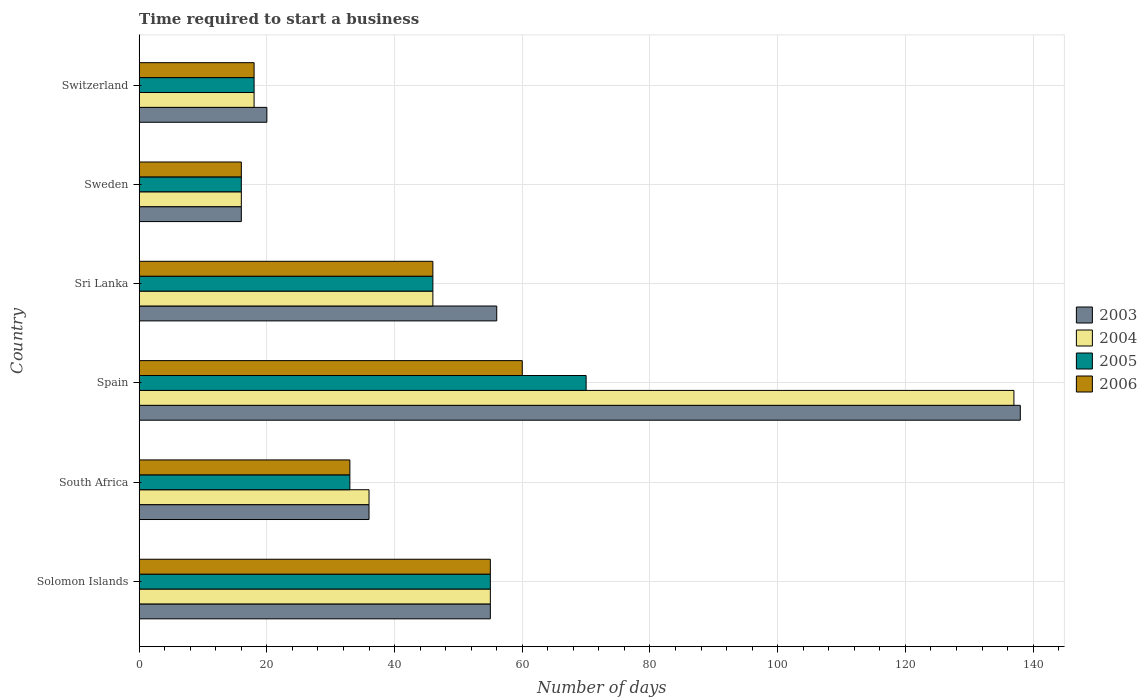How many groups of bars are there?
Your response must be concise. 6. Are the number of bars per tick equal to the number of legend labels?
Your answer should be compact. Yes. Are the number of bars on each tick of the Y-axis equal?
Keep it short and to the point. Yes. In how many cases, is the number of bars for a given country not equal to the number of legend labels?
Make the answer very short. 0. Across all countries, what is the maximum number of days required to start a business in 2004?
Make the answer very short. 137. In which country was the number of days required to start a business in 2006 maximum?
Give a very brief answer. Spain. What is the total number of days required to start a business in 2005 in the graph?
Provide a succinct answer. 238. What is the average number of days required to start a business in 2004 per country?
Your answer should be very brief. 51.33. What is the difference between the number of days required to start a business in 2004 and number of days required to start a business in 2006 in Switzerland?
Give a very brief answer. 0. In how many countries, is the number of days required to start a business in 2004 greater than 20 days?
Keep it short and to the point. 4. What is the ratio of the number of days required to start a business in 2005 in Solomon Islands to that in Sri Lanka?
Provide a succinct answer. 1.2. Is the difference between the number of days required to start a business in 2004 in South Africa and Spain greater than the difference between the number of days required to start a business in 2006 in South Africa and Spain?
Your response must be concise. No. What is the difference between the highest and the second highest number of days required to start a business in 2005?
Offer a terse response. 15. In how many countries, is the number of days required to start a business in 2003 greater than the average number of days required to start a business in 2003 taken over all countries?
Provide a short and direct response. 3. Is the sum of the number of days required to start a business in 2006 in Solomon Islands and Spain greater than the maximum number of days required to start a business in 2004 across all countries?
Provide a short and direct response. No. Is it the case that in every country, the sum of the number of days required to start a business in 2004 and number of days required to start a business in 2005 is greater than the number of days required to start a business in 2006?
Provide a short and direct response. Yes. How many bars are there?
Your response must be concise. 24. How many countries are there in the graph?
Give a very brief answer. 6. Are the values on the major ticks of X-axis written in scientific E-notation?
Provide a succinct answer. No. Does the graph contain any zero values?
Provide a succinct answer. No. Does the graph contain grids?
Keep it short and to the point. Yes. Where does the legend appear in the graph?
Keep it short and to the point. Center right. What is the title of the graph?
Offer a very short reply. Time required to start a business. Does "1990" appear as one of the legend labels in the graph?
Make the answer very short. No. What is the label or title of the X-axis?
Offer a terse response. Number of days. What is the label or title of the Y-axis?
Your answer should be very brief. Country. What is the Number of days of 2004 in South Africa?
Give a very brief answer. 36. What is the Number of days of 2006 in South Africa?
Your response must be concise. 33. What is the Number of days in 2003 in Spain?
Ensure brevity in your answer.  138. What is the Number of days in 2004 in Spain?
Give a very brief answer. 137. What is the Number of days in 2005 in Spain?
Provide a short and direct response. 70. What is the Number of days in 2006 in Spain?
Ensure brevity in your answer.  60. What is the Number of days in 2004 in Sri Lanka?
Your answer should be very brief. 46. What is the Number of days in 2004 in Sweden?
Offer a very short reply. 16. What is the Number of days in 2005 in Sweden?
Give a very brief answer. 16. What is the Number of days of 2006 in Sweden?
Provide a succinct answer. 16. What is the Number of days in 2003 in Switzerland?
Your response must be concise. 20. Across all countries, what is the maximum Number of days of 2003?
Make the answer very short. 138. Across all countries, what is the maximum Number of days of 2004?
Keep it short and to the point. 137. Across all countries, what is the maximum Number of days in 2005?
Make the answer very short. 70. Across all countries, what is the minimum Number of days of 2003?
Offer a terse response. 16. Across all countries, what is the minimum Number of days of 2004?
Offer a very short reply. 16. What is the total Number of days of 2003 in the graph?
Give a very brief answer. 321. What is the total Number of days of 2004 in the graph?
Give a very brief answer. 308. What is the total Number of days of 2005 in the graph?
Make the answer very short. 238. What is the total Number of days in 2006 in the graph?
Give a very brief answer. 228. What is the difference between the Number of days in 2005 in Solomon Islands and that in South Africa?
Provide a short and direct response. 22. What is the difference between the Number of days in 2003 in Solomon Islands and that in Spain?
Keep it short and to the point. -83. What is the difference between the Number of days of 2004 in Solomon Islands and that in Spain?
Keep it short and to the point. -82. What is the difference between the Number of days of 2006 in Solomon Islands and that in Spain?
Your answer should be compact. -5. What is the difference between the Number of days in 2004 in Solomon Islands and that in Sri Lanka?
Offer a terse response. 9. What is the difference between the Number of days in 2005 in Solomon Islands and that in Sri Lanka?
Your response must be concise. 9. What is the difference between the Number of days of 2003 in Solomon Islands and that in Sweden?
Your answer should be very brief. 39. What is the difference between the Number of days of 2005 in Solomon Islands and that in Sweden?
Your answer should be very brief. 39. What is the difference between the Number of days in 2006 in Solomon Islands and that in Sweden?
Your response must be concise. 39. What is the difference between the Number of days of 2004 in Solomon Islands and that in Switzerland?
Provide a succinct answer. 37. What is the difference between the Number of days in 2003 in South Africa and that in Spain?
Make the answer very short. -102. What is the difference between the Number of days of 2004 in South Africa and that in Spain?
Provide a short and direct response. -101. What is the difference between the Number of days of 2005 in South Africa and that in Spain?
Provide a succinct answer. -37. What is the difference between the Number of days in 2004 in South Africa and that in Sri Lanka?
Your answer should be very brief. -10. What is the difference between the Number of days of 2004 in South Africa and that in Sweden?
Provide a succinct answer. 20. What is the difference between the Number of days in 2006 in South Africa and that in Sweden?
Your response must be concise. 17. What is the difference between the Number of days of 2004 in South Africa and that in Switzerland?
Ensure brevity in your answer.  18. What is the difference between the Number of days in 2003 in Spain and that in Sri Lanka?
Give a very brief answer. 82. What is the difference between the Number of days of 2004 in Spain and that in Sri Lanka?
Give a very brief answer. 91. What is the difference between the Number of days of 2006 in Spain and that in Sri Lanka?
Provide a short and direct response. 14. What is the difference between the Number of days of 2003 in Spain and that in Sweden?
Your answer should be compact. 122. What is the difference between the Number of days of 2004 in Spain and that in Sweden?
Provide a short and direct response. 121. What is the difference between the Number of days of 2003 in Spain and that in Switzerland?
Provide a succinct answer. 118. What is the difference between the Number of days in 2004 in Spain and that in Switzerland?
Your response must be concise. 119. What is the difference between the Number of days in 2003 in Sri Lanka and that in Sweden?
Your response must be concise. 40. What is the difference between the Number of days in 2004 in Sri Lanka and that in Sweden?
Offer a terse response. 30. What is the difference between the Number of days of 2005 in Sri Lanka and that in Sweden?
Your answer should be compact. 30. What is the difference between the Number of days in 2003 in Sri Lanka and that in Switzerland?
Offer a very short reply. 36. What is the difference between the Number of days in 2003 in Sweden and that in Switzerland?
Keep it short and to the point. -4. What is the difference between the Number of days in 2003 in Solomon Islands and the Number of days in 2006 in South Africa?
Ensure brevity in your answer.  22. What is the difference between the Number of days in 2004 in Solomon Islands and the Number of days in 2005 in South Africa?
Your response must be concise. 22. What is the difference between the Number of days of 2003 in Solomon Islands and the Number of days of 2004 in Spain?
Make the answer very short. -82. What is the difference between the Number of days in 2003 in Solomon Islands and the Number of days in 2005 in Spain?
Provide a short and direct response. -15. What is the difference between the Number of days of 2003 in Solomon Islands and the Number of days of 2006 in Spain?
Offer a terse response. -5. What is the difference between the Number of days of 2004 in Solomon Islands and the Number of days of 2005 in Spain?
Ensure brevity in your answer.  -15. What is the difference between the Number of days in 2003 in Solomon Islands and the Number of days in 2004 in Sri Lanka?
Make the answer very short. 9. What is the difference between the Number of days in 2003 in Solomon Islands and the Number of days in 2006 in Sri Lanka?
Provide a short and direct response. 9. What is the difference between the Number of days of 2004 in Solomon Islands and the Number of days of 2005 in Sri Lanka?
Offer a terse response. 9. What is the difference between the Number of days in 2005 in Solomon Islands and the Number of days in 2006 in Sri Lanka?
Your answer should be compact. 9. What is the difference between the Number of days in 2003 in Solomon Islands and the Number of days in 2004 in Sweden?
Your answer should be compact. 39. What is the difference between the Number of days of 2003 in Solomon Islands and the Number of days of 2006 in Sweden?
Your answer should be compact. 39. What is the difference between the Number of days in 2004 in Solomon Islands and the Number of days in 2005 in Sweden?
Keep it short and to the point. 39. What is the difference between the Number of days in 2004 in Solomon Islands and the Number of days in 2006 in Sweden?
Your answer should be very brief. 39. What is the difference between the Number of days of 2003 in Solomon Islands and the Number of days of 2004 in Switzerland?
Give a very brief answer. 37. What is the difference between the Number of days of 2004 in Solomon Islands and the Number of days of 2005 in Switzerland?
Keep it short and to the point. 37. What is the difference between the Number of days of 2004 in Solomon Islands and the Number of days of 2006 in Switzerland?
Provide a succinct answer. 37. What is the difference between the Number of days of 2005 in Solomon Islands and the Number of days of 2006 in Switzerland?
Offer a very short reply. 37. What is the difference between the Number of days in 2003 in South Africa and the Number of days in 2004 in Spain?
Your answer should be very brief. -101. What is the difference between the Number of days of 2003 in South Africa and the Number of days of 2005 in Spain?
Make the answer very short. -34. What is the difference between the Number of days of 2003 in South Africa and the Number of days of 2006 in Spain?
Offer a very short reply. -24. What is the difference between the Number of days in 2004 in South Africa and the Number of days in 2005 in Spain?
Offer a very short reply. -34. What is the difference between the Number of days in 2004 in South Africa and the Number of days in 2005 in Sri Lanka?
Make the answer very short. -10. What is the difference between the Number of days in 2004 in South Africa and the Number of days in 2006 in Sri Lanka?
Ensure brevity in your answer.  -10. What is the difference between the Number of days in 2003 in South Africa and the Number of days in 2004 in Sweden?
Your response must be concise. 20. What is the difference between the Number of days in 2003 in South Africa and the Number of days in 2005 in Sweden?
Make the answer very short. 20. What is the difference between the Number of days of 2005 in South Africa and the Number of days of 2006 in Sweden?
Provide a succinct answer. 17. What is the difference between the Number of days of 2003 in South Africa and the Number of days of 2004 in Switzerland?
Provide a succinct answer. 18. What is the difference between the Number of days of 2004 in South Africa and the Number of days of 2005 in Switzerland?
Give a very brief answer. 18. What is the difference between the Number of days in 2005 in South Africa and the Number of days in 2006 in Switzerland?
Your answer should be very brief. 15. What is the difference between the Number of days in 2003 in Spain and the Number of days in 2004 in Sri Lanka?
Offer a very short reply. 92. What is the difference between the Number of days of 2003 in Spain and the Number of days of 2005 in Sri Lanka?
Provide a short and direct response. 92. What is the difference between the Number of days of 2003 in Spain and the Number of days of 2006 in Sri Lanka?
Give a very brief answer. 92. What is the difference between the Number of days of 2004 in Spain and the Number of days of 2005 in Sri Lanka?
Provide a short and direct response. 91. What is the difference between the Number of days in 2004 in Spain and the Number of days in 2006 in Sri Lanka?
Your answer should be compact. 91. What is the difference between the Number of days in 2003 in Spain and the Number of days in 2004 in Sweden?
Provide a short and direct response. 122. What is the difference between the Number of days in 2003 in Spain and the Number of days in 2005 in Sweden?
Offer a very short reply. 122. What is the difference between the Number of days in 2003 in Spain and the Number of days in 2006 in Sweden?
Make the answer very short. 122. What is the difference between the Number of days of 2004 in Spain and the Number of days of 2005 in Sweden?
Offer a very short reply. 121. What is the difference between the Number of days of 2004 in Spain and the Number of days of 2006 in Sweden?
Offer a very short reply. 121. What is the difference between the Number of days in 2005 in Spain and the Number of days in 2006 in Sweden?
Make the answer very short. 54. What is the difference between the Number of days in 2003 in Spain and the Number of days in 2004 in Switzerland?
Keep it short and to the point. 120. What is the difference between the Number of days of 2003 in Spain and the Number of days of 2005 in Switzerland?
Provide a succinct answer. 120. What is the difference between the Number of days of 2003 in Spain and the Number of days of 2006 in Switzerland?
Keep it short and to the point. 120. What is the difference between the Number of days in 2004 in Spain and the Number of days in 2005 in Switzerland?
Provide a succinct answer. 119. What is the difference between the Number of days of 2004 in Spain and the Number of days of 2006 in Switzerland?
Your response must be concise. 119. What is the difference between the Number of days of 2005 in Spain and the Number of days of 2006 in Switzerland?
Provide a succinct answer. 52. What is the difference between the Number of days of 2003 in Sri Lanka and the Number of days of 2004 in Sweden?
Offer a very short reply. 40. What is the difference between the Number of days of 2004 in Sri Lanka and the Number of days of 2005 in Sweden?
Give a very brief answer. 30. What is the difference between the Number of days in 2004 in Sri Lanka and the Number of days in 2006 in Sweden?
Ensure brevity in your answer.  30. What is the difference between the Number of days of 2003 in Sri Lanka and the Number of days of 2005 in Switzerland?
Provide a short and direct response. 38. What is the difference between the Number of days of 2003 in Sri Lanka and the Number of days of 2006 in Switzerland?
Ensure brevity in your answer.  38. What is the difference between the Number of days in 2004 in Sri Lanka and the Number of days in 2005 in Switzerland?
Provide a succinct answer. 28. What is the difference between the Number of days in 2005 in Sri Lanka and the Number of days in 2006 in Switzerland?
Provide a succinct answer. 28. What is the difference between the Number of days in 2003 in Sweden and the Number of days in 2006 in Switzerland?
Offer a terse response. -2. What is the difference between the Number of days of 2005 in Sweden and the Number of days of 2006 in Switzerland?
Provide a succinct answer. -2. What is the average Number of days of 2003 per country?
Your answer should be very brief. 53.5. What is the average Number of days of 2004 per country?
Your answer should be very brief. 51.33. What is the average Number of days in 2005 per country?
Your response must be concise. 39.67. What is the average Number of days in 2006 per country?
Ensure brevity in your answer.  38. What is the difference between the Number of days in 2003 and Number of days in 2004 in Solomon Islands?
Offer a very short reply. 0. What is the difference between the Number of days of 2003 and Number of days of 2006 in Solomon Islands?
Keep it short and to the point. 0. What is the difference between the Number of days of 2004 and Number of days of 2005 in Solomon Islands?
Your answer should be compact. 0. What is the difference between the Number of days in 2003 and Number of days in 2004 in South Africa?
Provide a succinct answer. 0. What is the difference between the Number of days of 2003 and Number of days of 2005 in South Africa?
Offer a terse response. 3. What is the difference between the Number of days of 2004 and Number of days of 2005 in South Africa?
Keep it short and to the point. 3. What is the difference between the Number of days of 2003 and Number of days of 2006 in Spain?
Give a very brief answer. 78. What is the difference between the Number of days in 2004 and Number of days in 2005 in Spain?
Ensure brevity in your answer.  67. What is the difference between the Number of days in 2004 and Number of days in 2006 in Spain?
Offer a very short reply. 77. What is the difference between the Number of days of 2005 and Number of days of 2006 in Spain?
Provide a succinct answer. 10. What is the difference between the Number of days of 2003 and Number of days of 2005 in Sri Lanka?
Make the answer very short. 10. What is the difference between the Number of days in 2003 and Number of days in 2005 in Sweden?
Your answer should be very brief. 0. What is the difference between the Number of days in 2003 and Number of days in 2006 in Sweden?
Offer a terse response. 0. What is the difference between the Number of days in 2004 and Number of days in 2005 in Sweden?
Keep it short and to the point. 0. What is the difference between the Number of days of 2004 and Number of days of 2006 in Switzerland?
Make the answer very short. 0. What is the ratio of the Number of days of 2003 in Solomon Islands to that in South Africa?
Make the answer very short. 1.53. What is the ratio of the Number of days of 2004 in Solomon Islands to that in South Africa?
Your answer should be compact. 1.53. What is the ratio of the Number of days of 2005 in Solomon Islands to that in South Africa?
Ensure brevity in your answer.  1.67. What is the ratio of the Number of days in 2006 in Solomon Islands to that in South Africa?
Offer a terse response. 1.67. What is the ratio of the Number of days in 2003 in Solomon Islands to that in Spain?
Give a very brief answer. 0.4. What is the ratio of the Number of days in 2004 in Solomon Islands to that in Spain?
Ensure brevity in your answer.  0.4. What is the ratio of the Number of days in 2005 in Solomon Islands to that in Spain?
Keep it short and to the point. 0.79. What is the ratio of the Number of days of 2006 in Solomon Islands to that in Spain?
Your response must be concise. 0.92. What is the ratio of the Number of days in 2003 in Solomon Islands to that in Sri Lanka?
Provide a succinct answer. 0.98. What is the ratio of the Number of days in 2004 in Solomon Islands to that in Sri Lanka?
Your response must be concise. 1.2. What is the ratio of the Number of days in 2005 in Solomon Islands to that in Sri Lanka?
Ensure brevity in your answer.  1.2. What is the ratio of the Number of days of 2006 in Solomon Islands to that in Sri Lanka?
Your response must be concise. 1.2. What is the ratio of the Number of days of 2003 in Solomon Islands to that in Sweden?
Ensure brevity in your answer.  3.44. What is the ratio of the Number of days in 2004 in Solomon Islands to that in Sweden?
Your response must be concise. 3.44. What is the ratio of the Number of days of 2005 in Solomon Islands to that in Sweden?
Offer a very short reply. 3.44. What is the ratio of the Number of days in 2006 in Solomon Islands to that in Sweden?
Keep it short and to the point. 3.44. What is the ratio of the Number of days in 2003 in Solomon Islands to that in Switzerland?
Provide a succinct answer. 2.75. What is the ratio of the Number of days of 2004 in Solomon Islands to that in Switzerland?
Offer a very short reply. 3.06. What is the ratio of the Number of days in 2005 in Solomon Islands to that in Switzerland?
Your response must be concise. 3.06. What is the ratio of the Number of days in 2006 in Solomon Islands to that in Switzerland?
Ensure brevity in your answer.  3.06. What is the ratio of the Number of days of 2003 in South Africa to that in Spain?
Offer a terse response. 0.26. What is the ratio of the Number of days of 2004 in South Africa to that in Spain?
Provide a short and direct response. 0.26. What is the ratio of the Number of days in 2005 in South Africa to that in Spain?
Your response must be concise. 0.47. What is the ratio of the Number of days of 2006 in South Africa to that in Spain?
Ensure brevity in your answer.  0.55. What is the ratio of the Number of days in 2003 in South Africa to that in Sri Lanka?
Provide a succinct answer. 0.64. What is the ratio of the Number of days of 2004 in South Africa to that in Sri Lanka?
Offer a terse response. 0.78. What is the ratio of the Number of days of 2005 in South Africa to that in Sri Lanka?
Provide a succinct answer. 0.72. What is the ratio of the Number of days of 2006 in South Africa to that in Sri Lanka?
Make the answer very short. 0.72. What is the ratio of the Number of days in 2003 in South Africa to that in Sweden?
Make the answer very short. 2.25. What is the ratio of the Number of days in 2004 in South Africa to that in Sweden?
Offer a very short reply. 2.25. What is the ratio of the Number of days of 2005 in South Africa to that in Sweden?
Ensure brevity in your answer.  2.06. What is the ratio of the Number of days in 2006 in South Africa to that in Sweden?
Keep it short and to the point. 2.06. What is the ratio of the Number of days in 2003 in South Africa to that in Switzerland?
Offer a very short reply. 1.8. What is the ratio of the Number of days of 2005 in South Africa to that in Switzerland?
Keep it short and to the point. 1.83. What is the ratio of the Number of days of 2006 in South Africa to that in Switzerland?
Provide a succinct answer. 1.83. What is the ratio of the Number of days in 2003 in Spain to that in Sri Lanka?
Your answer should be very brief. 2.46. What is the ratio of the Number of days in 2004 in Spain to that in Sri Lanka?
Your answer should be very brief. 2.98. What is the ratio of the Number of days of 2005 in Spain to that in Sri Lanka?
Offer a very short reply. 1.52. What is the ratio of the Number of days in 2006 in Spain to that in Sri Lanka?
Your response must be concise. 1.3. What is the ratio of the Number of days of 2003 in Spain to that in Sweden?
Ensure brevity in your answer.  8.62. What is the ratio of the Number of days in 2004 in Spain to that in Sweden?
Give a very brief answer. 8.56. What is the ratio of the Number of days in 2005 in Spain to that in Sweden?
Ensure brevity in your answer.  4.38. What is the ratio of the Number of days of 2006 in Spain to that in Sweden?
Provide a succinct answer. 3.75. What is the ratio of the Number of days of 2003 in Spain to that in Switzerland?
Offer a very short reply. 6.9. What is the ratio of the Number of days of 2004 in Spain to that in Switzerland?
Ensure brevity in your answer.  7.61. What is the ratio of the Number of days in 2005 in Spain to that in Switzerland?
Your answer should be very brief. 3.89. What is the ratio of the Number of days of 2004 in Sri Lanka to that in Sweden?
Offer a terse response. 2.88. What is the ratio of the Number of days in 2005 in Sri Lanka to that in Sweden?
Offer a very short reply. 2.88. What is the ratio of the Number of days in 2006 in Sri Lanka to that in Sweden?
Keep it short and to the point. 2.88. What is the ratio of the Number of days of 2004 in Sri Lanka to that in Switzerland?
Give a very brief answer. 2.56. What is the ratio of the Number of days of 2005 in Sri Lanka to that in Switzerland?
Your answer should be compact. 2.56. What is the ratio of the Number of days of 2006 in Sri Lanka to that in Switzerland?
Provide a succinct answer. 2.56. What is the ratio of the Number of days of 2004 in Sweden to that in Switzerland?
Provide a short and direct response. 0.89. What is the difference between the highest and the second highest Number of days in 2003?
Your answer should be compact. 82. What is the difference between the highest and the second highest Number of days of 2004?
Your answer should be compact. 82. What is the difference between the highest and the lowest Number of days of 2003?
Provide a succinct answer. 122. What is the difference between the highest and the lowest Number of days in 2004?
Give a very brief answer. 121. What is the difference between the highest and the lowest Number of days in 2006?
Provide a succinct answer. 44. 